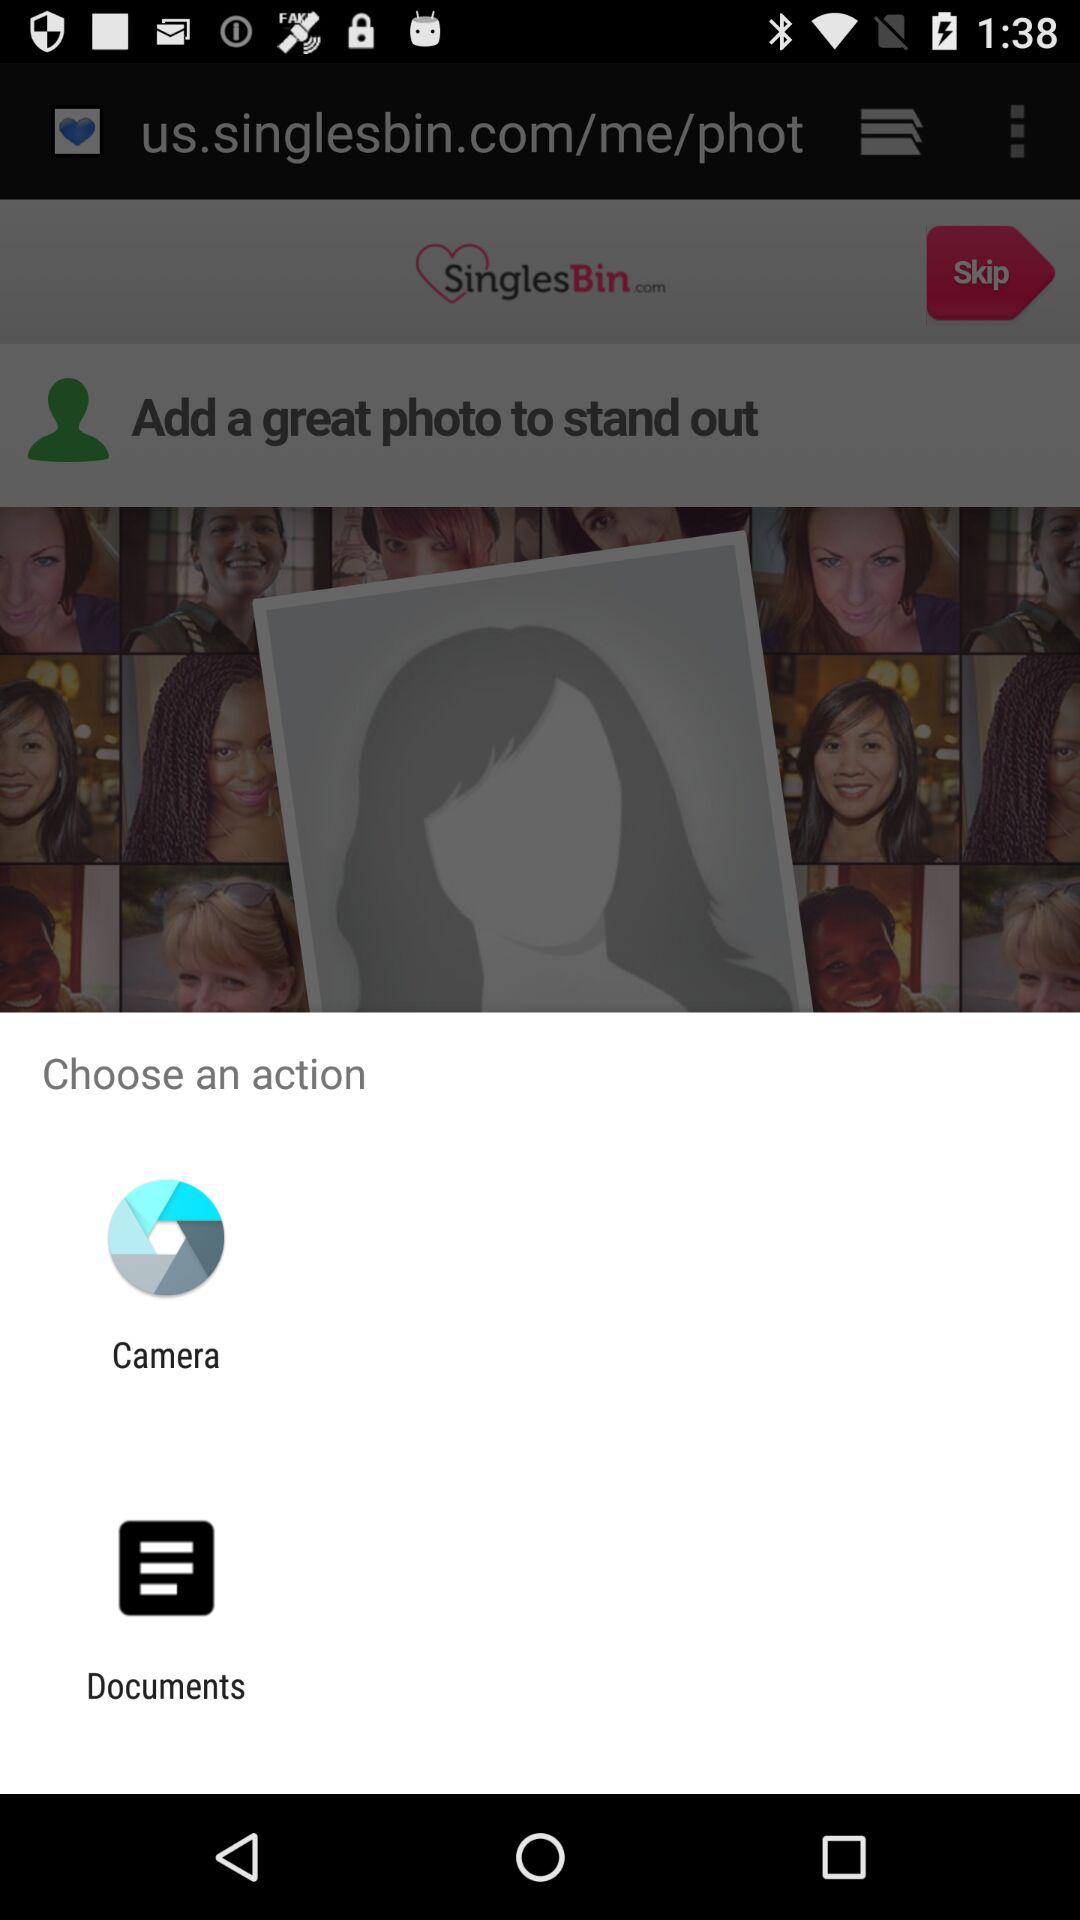Which app can we use to open the content? The apps that you can use to open the content are "Camera" and "Documents". 